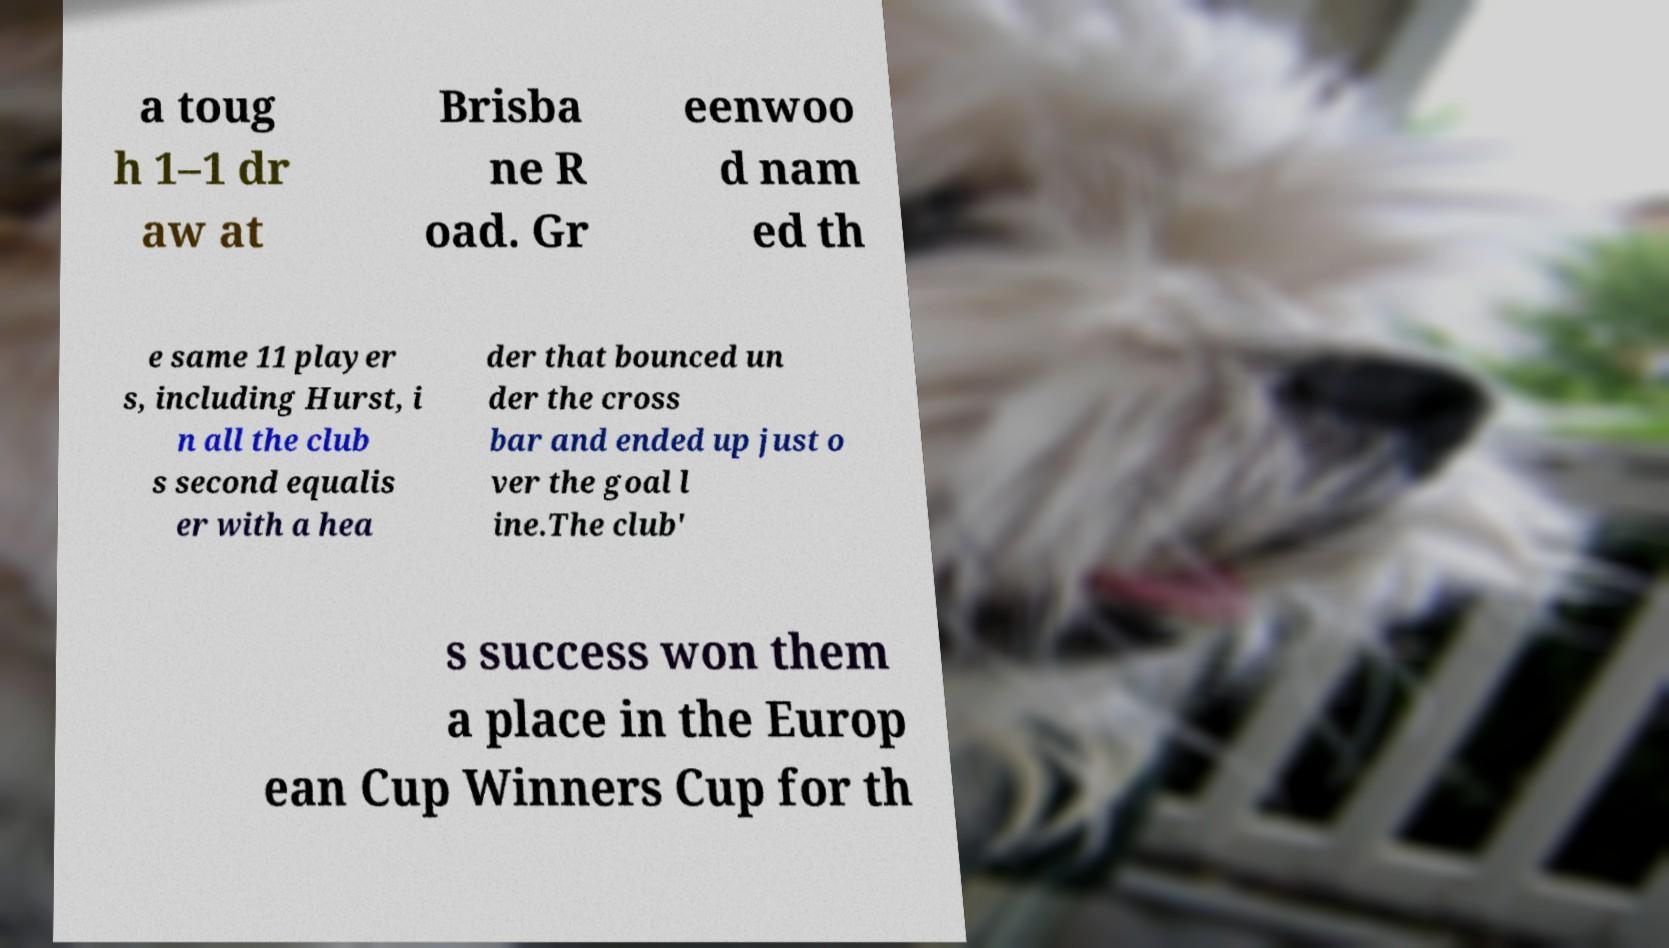Please read and relay the text visible in this image. What does it say? a toug h 1–1 dr aw at Brisba ne R oad. Gr eenwoo d nam ed th e same 11 player s, including Hurst, i n all the club s second equalis er with a hea der that bounced un der the cross bar and ended up just o ver the goal l ine.The club' s success won them a place in the Europ ean Cup Winners Cup for th 